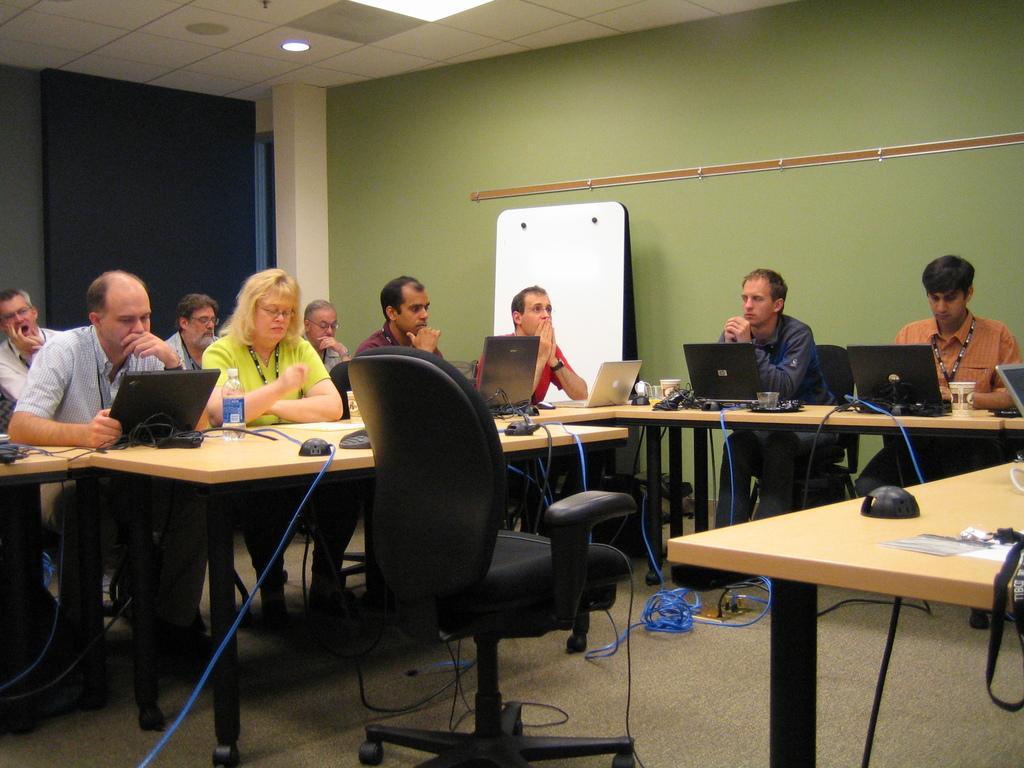Describe this image in one or two sentences. This picture is taken inside the room, There are some table which are in yellow colors and there are some laptops which are in black color, There are some people sitting on the chairs, In the background there is a green color wall and a black color door, In the top there is a white color roof. 